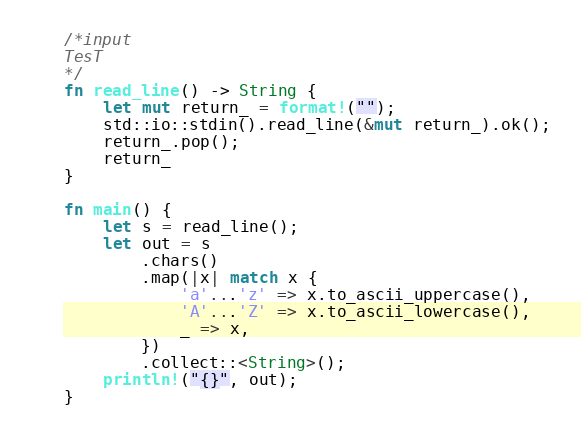Convert code to text. <code><loc_0><loc_0><loc_500><loc_500><_Rust_>/*input
TesT
*/
fn read_line() -> String {
    let mut return_ = format!("");
    std::io::stdin().read_line(&mut return_).ok();
    return_.pop();
    return_
}

fn main() {
    let s = read_line();
    let out = s
        .chars()
        .map(|x| match x {
            'a'...'z' => x.to_ascii_uppercase(),
            'A'...'Z' => x.to_ascii_lowercase(),
            _ => x,
        })
        .collect::<String>();
    println!("{}", out);
}

</code> 